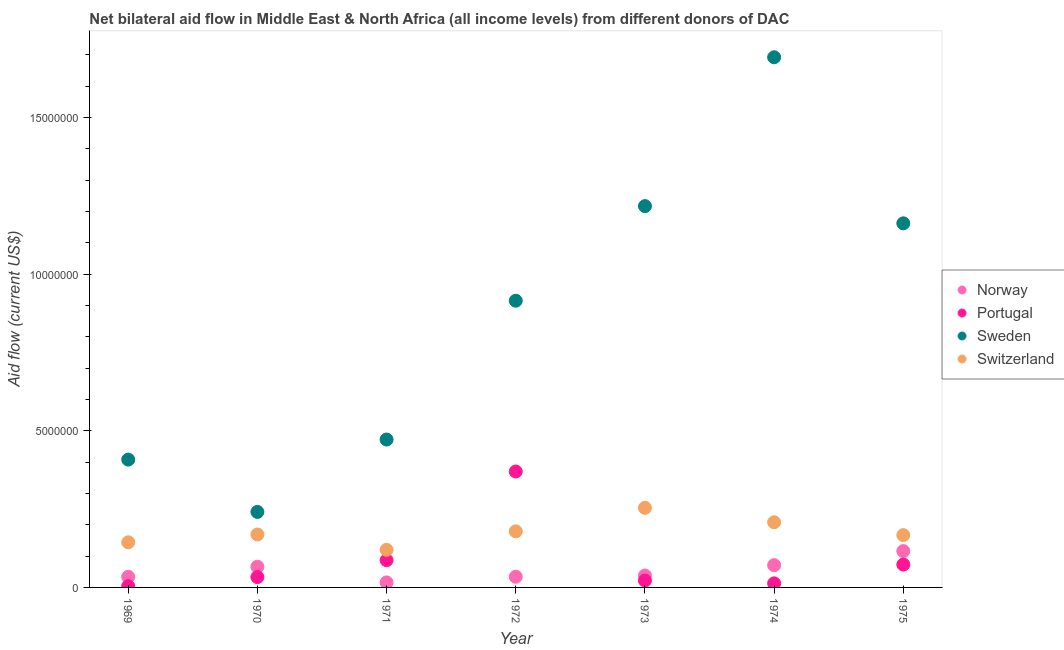How many different coloured dotlines are there?
Offer a terse response. 4. Is the number of dotlines equal to the number of legend labels?
Provide a succinct answer. Yes. What is the amount of aid given by norway in 1973?
Provide a short and direct response. 3.80e+05. Across all years, what is the maximum amount of aid given by norway?
Keep it short and to the point. 1.16e+06. Across all years, what is the minimum amount of aid given by norway?
Provide a succinct answer. 1.60e+05. In which year was the amount of aid given by portugal minimum?
Make the answer very short. 1969. What is the total amount of aid given by sweden in the graph?
Keep it short and to the point. 6.11e+07. What is the difference between the amount of aid given by switzerland in 1969 and that in 1972?
Offer a very short reply. -3.50e+05. What is the difference between the amount of aid given by switzerland in 1969 and the amount of aid given by portugal in 1970?
Ensure brevity in your answer.  1.11e+06. What is the average amount of aid given by portugal per year?
Your response must be concise. 8.60e+05. In the year 1975, what is the difference between the amount of aid given by portugal and amount of aid given by norway?
Offer a very short reply. -4.30e+05. What is the ratio of the amount of aid given by norway in 1974 to that in 1975?
Provide a succinct answer. 0.61. What is the difference between the highest and the lowest amount of aid given by switzerland?
Give a very brief answer. 1.34e+06. In how many years, is the amount of aid given by portugal greater than the average amount of aid given by portugal taken over all years?
Provide a short and direct response. 2. Is the sum of the amount of aid given by sweden in 1973 and 1975 greater than the maximum amount of aid given by norway across all years?
Your answer should be compact. Yes. Is the amount of aid given by switzerland strictly greater than the amount of aid given by sweden over the years?
Give a very brief answer. No. Does the graph contain grids?
Give a very brief answer. No. How many legend labels are there?
Make the answer very short. 4. How are the legend labels stacked?
Keep it short and to the point. Vertical. What is the title of the graph?
Give a very brief answer. Net bilateral aid flow in Middle East & North Africa (all income levels) from different donors of DAC. What is the label or title of the Y-axis?
Keep it short and to the point. Aid flow (current US$). What is the Aid flow (current US$) of Sweden in 1969?
Provide a succinct answer. 4.08e+06. What is the Aid flow (current US$) in Switzerland in 1969?
Offer a very short reply. 1.44e+06. What is the Aid flow (current US$) of Sweden in 1970?
Keep it short and to the point. 2.41e+06. What is the Aid flow (current US$) of Switzerland in 1970?
Keep it short and to the point. 1.69e+06. What is the Aid flow (current US$) of Norway in 1971?
Your response must be concise. 1.60e+05. What is the Aid flow (current US$) of Portugal in 1971?
Offer a terse response. 8.70e+05. What is the Aid flow (current US$) of Sweden in 1971?
Make the answer very short. 4.72e+06. What is the Aid flow (current US$) of Switzerland in 1971?
Your response must be concise. 1.20e+06. What is the Aid flow (current US$) of Norway in 1972?
Your response must be concise. 3.40e+05. What is the Aid flow (current US$) in Portugal in 1972?
Make the answer very short. 3.70e+06. What is the Aid flow (current US$) of Sweden in 1972?
Offer a terse response. 9.15e+06. What is the Aid flow (current US$) in Switzerland in 1972?
Offer a very short reply. 1.79e+06. What is the Aid flow (current US$) in Sweden in 1973?
Offer a terse response. 1.22e+07. What is the Aid flow (current US$) in Switzerland in 1973?
Provide a succinct answer. 2.54e+06. What is the Aid flow (current US$) in Norway in 1974?
Provide a succinct answer. 7.10e+05. What is the Aid flow (current US$) in Portugal in 1974?
Provide a succinct answer. 1.30e+05. What is the Aid flow (current US$) in Sweden in 1974?
Give a very brief answer. 1.69e+07. What is the Aid flow (current US$) in Switzerland in 1974?
Your response must be concise. 2.08e+06. What is the Aid flow (current US$) of Norway in 1975?
Offer a very short reply. 1.16e+06. What is the Aid flow (current US$) in Portugal in 1975?
Offer a very short reply. 7.30e+05. What is the Aid flow (current US$) of Sweden in 1975?
Provide a short and direct response. 1.16e+07. What is the Aid flow (current US$) in Switzerland in 1975?
Offer a very short reply. 1.67e+06. Across all years, what is the maximum Aid flow (current US$) in Norway?
Offer a terse response. 1.16e+06. Across all years, what is the maximum Aid flow (current US$) of Portugal?
Make the answer very short. 3.70e+06. Across all years, what is the maximum Aid flow (current US$) of Sweden?
Your response must be concise. 1.69e+07. Across all years, what is the maximum Aid flow (current US$) in Switzerland?
Provide a succinct answer. 2.54e+06. Across all years, what is the minimum Aid flow (current US$) of Norway?
Provide a succinct answer. 1.60e+05. Across all years, what is the minimum Aid flow (current US$) in Sweden?
Provide a succinct answer. 2.41e+06. Across all years, what is the minimum Aid flow (current US$) in Switzerland?
Your response must be concise. 1.20e+06. What is the total Aid flow (current US$) of Norway in the graph?
Offer a very short reply. 3.75e+06. What is the total Aid flow (current US$) of Portugal in the graph?
Provide a succinct answer. 6.02e+06. What is the total Aid flow (current US$) of Sweden in the graph?
Make the answer very short. 6.11e+07. What is the total Aid flow (current US$) in Switzerland in the graph?
Keep it short and to the point. 1.24e+07. What is the difference between the Aid flow (current US$) of Norway in 1969 and that in 1970?
Provide a succinct answer. -3.20e+05. What is the difference between the Aid flow (current US$) in Portugal in 1969 and that in 1970?
Give a very brief answer. -2.90e+05. What is the difference between the Aid flow (current US$) in Sweden in 1969 and that in 1970?
Ensure brevity in your answer.  1.67e+06. What is the difference between the Aid flow (current US$) in Switzerland in 1969 and that in 1970?
Keep it short and to the point. -2.50e+05. What is the difference between the Aid flow (current US$) in Portugal in 1969 and that in 1971?
Offer a very short reply. -8.30e+05. What is the difference between the Aid flow (current US$) of Sweden in 1969 and that in 1971?
Offer a very short reply. -6.40e+05. What is the difference between the Aid flow (current US$) in Switzerland in 1969 and that in 1971?
Your response must be concise. 2.40e+05. What is the difference between the Aid flow (current US$) of Portugal in 1969 and that in 1972?
Keep it short and to the point. -3.66e+06. What is the difference between the Aid flow (current US$) of Sweden in 1969 and that in 1972?
Provide a succinct answer. -5.07e+06. What is the difference between the Aid flow (current US$) of Switzerland in 1969 and that in 1972?
Keep it short and to the point. -3.50e+05. What is the difference between the Aid flow (current US$) of Sweden in 1969 and that in 1973?
Offer a very short reply. -8.09e+06. What is the difference between the Aid flow (current US$) of Switzerland in 1969 and that in 1973?
Provide a succinct answer. -1.10e+06. What is the difference between the Aid flow (current US$) of Norway in 1969 and that in 1974?
Give a very brief answer. -3.70e+05. What is the difference between the Aid flow (current US$) of Portugal in 1969 and that in 1974?
Offer a terse response. -9.00e+04. What is the difference between the Aid flow (current US$) in Sweden in 1969 and that in 1974?
Provide a succinct answer. -1.28e+07. What is the difference between the Aid flow (current US$) in Switzerland in 1969 and that in 1974?
Provide a short and direct response. -6.40e+05. What is the difference between the Aid flow (current US$) in Norway in 1969 and that in 1975?
Provide a short and direct response. -8.20e+05. What is the difference between the Aid flow (current US$) of Portugal in 1969 and that in 1975?
Ensure brevity in your answer.  -6.90e+05. What is the difference between the Aid flow (current US$) in Sweden in 1969 and that in 1975?
Give a very brief answer. -7.54e+06. What is the difference between the Aid flow (current US$) in Norway in 1970 and that in 1971?
Ensure brevity in your answer.  5.00e+05. What is the difference between the Aid flow (current US$) in Portugal in 1970 and that in 1971?
Give a very brief answer. -5.40e+05. What is the difference between the Aid flow (current US$) of Sweden in 1970 and that in 1971?
Keep it short and to the point. -2.31e+06. What is the difference between the Aid flow (current US$) of Portugal in 1970 and that in 1972?
Keep it short and to the point. -3.37e+06. What is the difference between the Aid flow (current US$) in Sweden in 1970 and that in 1972?
Make the answer very short. -6.74e+06. What is the difference between the Aid flow (current US$) of Portugal in 1970 and that in 1973?
Your answer should be compact. 1.10e+05. What is the difference between the Aid flow (current US$) of Sweden in 1970 and that in 1973?
Offer a very short reply. -9.76e+06. What is the difference between the Aid flow (current US$) in Switzerland in 1970 and that in 1973?
Your answer should be very brief. -8.50e+05. What is the difference between the Aid flow (current US$) of Portugal in 1970 and that in 1974?
Provide a succinct answer. 2.00e+05. What is the difference between the Aid flow (current US$) in Sweden in 1970 and that in 1974?
Keep it short and to the point. -1.45e+07. What is the difference between the Aid flow (current US$) in Switzerland in 1970 and that in 1974?
Make the answer very short. -3.90e+05. What is the difference between the Aid flow (current US$) of Norway in 1970 and that in 1975?
Your answer should be very brief. -5.00e+05. What is the difference between the Aid flow (current US$) of Portugal in 1970 and that in 1975?
Your answer should be very brief. -4.00e+05. What is the difference between the Aid flow (current US$) in Sweden in 1970 and that in 1975?
Ensure brevity in your answer.  -9.21e+06. What is the difference between the Aid flow (current US$) of Switzerland in 1970 and that in 1975?
Provide a short and direct response. 2.00e+04. What is the difference between the Aid flow (current US$) of Portugal in 1971 and that in 1972?
Keep it short and to the point. -2.83e+06. What is the difference between the Aid flow (current US$) in Sweden in 1971 and that in 1972?
Your answer should be very brief. -4.43e+06. What is the difference between the Aid flow (current US$) in Switzerland in 1971 and that in 1972?
Give a very brief answer. -5.90e+05. What is the difference between the Aid flow (current US$) of Norway in 1971 and that in 1973?
Offer a terse response. -2.20e+05. What is the difference between the Aid flow (current US$) of Portugal in 1971 and that in 1973?
Your response must be concise. 6.50e+05. What is the difference between the Aid flow (current US$) in Sweden in 1971 and that in 1973?
Your answer should be very brief. -7.45e+06. What is the difference between the Aid flow (current US$) of Switzerland in 1971 and that in 1973?
Keep it short and to the point. -1.34e+06. What is the difference between the Aid flow (current US$) of Norway in 1971 and that in 1974?
Your answer should be compact. -5.50e+05. What is the difference between the Aid flow (current US$) of Portugal in 1971 and that in 1974?
Give a very brief answer. 7.40e+05. What is the difference between the Aid flow (current US$) in Sweden in 1971 and that in 1974?
Your response must be concise. -1.22e+07. What is the difference between the Aid flow (current US$) in Switzerland in 1971 and that in 1974?
Offer a terse response. -8.80e+05. What is the difference between the Aid flow (current US$) in Norway in 1971 and that in 1975?
Provide a succinct answer. -1.00e+06. What is the difference between the Aid flow (current US$) of Sweden in 1971 and that in 1975?
Ensure brevity in your answer.  -6.90e+06. What is the difference between the Aid flow (current US$) of Switzerland in 1971 and that in 1975?
Offer a terse response. -4.70e+05. What is the difference between the Aid flow (current US$) of Portugal in 1972 and that in 1973?
Your answer should be compact. 3.48e+06. What is the difference between the Aid flow (current US$) of Sweden in 1972 and that in 1973?
Provide a succinct answer. -3.02e+06. What is the difference between the Aid flow (current US$) of Switzerland in 1972 and that in 1973?
Provide a short and direct response. -7.50e+05. What is the difference between the Aid flow (current US$) in Norway in 1972 and that in 1974?
Give a very brief answer. -3.70e+05. What is the difference between the Aid flow (current US$) in Portugal in 1972 and that in 1974?
Offer a very short reply. 3.57e+06. What is the difference between the Aid flow (current US$) in Sweden in 1972 and that in 1974?
Offer a very short reply. -7.77e+06. What is the difference between the Aid flow (current US$) in Norway in 1972 and that in 1975?
Ensure brevity in your answer.  -8.20e+05. What is the difference between the Aid flow (current US$) of Portugal in 1972 and that in 1975?
Make the answer very short. 2.97e+06. What is the difference between the Aid flow (current US$) in Sweden in 1972 and that in 1975?
Make the answer very short. -2.47e+06. What is the difference between the Aid flow (current US$) in Norway in 1973 and that in 1974?
Provide a short and direct response. -3.30e+05. What is the difference between the Aid flow (current US$) of Sweden in 1973 and that in 1974?
Provide a succinct answer. -4.75e+06. What is the difference between the Aid flow (current US$) in Norway in 1973 and that in 1975?
Your answer should be compact. -7.80e+05. What is the difference between the Aid flow (current US$) of Portugal in 1973 and that in 1975?
Ensure brevity in your answer.  -5.10e+05. What is the difference between the Aid flow (current US$) in Sweden in 1973 and that in 1975?
Make the answer very short. 5.50e+05. What is the difference between the Aid flow (current US$) in Switzerland in 1973 and that in 1975?
Your answer should be very brief. 8.70e+05. What is the difference between the Aid flow (current US$) of Norway in 1974 and that in 1975?
Provide a succinct answer. -4.50e+05. What is the difference between the Aid flow (current US$) of Portugal in 1974 and that in 1975?
Your answer should be very brief. -6.00e+05. What is the difference between the Aid flow (current US$) in Sweden in 1974 and that in 1975?
Your answer should be compact. 5.30e+06. What is the difference between the Aid flow (current US$) of Norway in 1969 and the Aid flow (current US$) of Portugal in 1970?
Offer a terse response. 10000. What is the difference between the Aid flow (current US$) in Norway in 1969 and the Aid flow (current US$) in Sweden in 1970?
Provide a short and direct response. -2.07e+06. What is the difference between the Aid flow (current US$) in Norway in 1969 and the Aid flow (current US$) in Switzerland in 1970?
Your response must be concise. -1.35e+06. What is the difference between the Aid flow (current US$) of Portugal in 1969 and the Aid flow (current US$) of Sweden in 1970?
Your response must be concise. -2.37e+06. What is the difference between the Aid flow (current US$) of Portugal in 1969 and the Aid flow (current US$) of Switzerland in 1970?
Provide a succinct answer. -1.65e+06. What is the difference between the Aid flow (current US$) in Sweden in 1969 and the Aid flow (current US$) in Switzerland in 1970?
Your response must be concise. 2.39e+06. What is the difference between the Aid flow (current US$) in Norway in 1969 and the Aid flow (current US$) in Portugal in 1971?
Make the answer very short. -5.30e+05. What is the difference between the Aid flow (current US$) of Norway in 1969 and the Aid flow (current US$) of Sweden in 1971?
Your answer should be very brief. -4.38e+06. What is the difference between the Aid flow (current US$) in Norway in 1969 and the Aid flow (current US$) in Switzerland in 1971?
Provide a short and direct response. -8.60e+05. What is the difference between the Aid flow (current US$) in Portugal in 1969 and the Aid flow (current US$) in Sweden in 1971?
Your answer should be very brief. -4.68e+06. What is the difference between the Aid flow (current US$) in Portugal in 1969 and the Aid flow (current US$) in Switzerland in 1971?
Your answer should be very brief. -1.16e+06. What is the difference between the Aid flow (current US$) in Sweden in 1969 and the Aid flow (current US$) in Switzerland in 1971?
Offer a terse response. 2.88e+06. What is the difference between the Aid flow (current US$) in Norway in 1969 and the Aid flow (current US$) in Portugal in 1972?
Provide a short and direct response. -3.36e+06. What is the difference between the Aid flow (current US$) of Norway in 1969 and the Aid flow (current US$) of Sweden in 1972?
Give a very brief answer. -8.81e+06. What is the difference between the Aid flow (current US$) in Norway in 1969 and the Aid flow (current US$) in Switzerland in 1972?
Keep it short and to the point. -1.45e+06. What is the difference between the Aid flow (current US$) of Portugal in 1969 and the Aid flow (current US$) of Sweden in 1972?
Give a very brief answer. -9.11e+06. What is the difference between the Aid flow (current US$) in Portugal in 1969 and the Aid flow (current US$) in Switzerland in 1972?
Provide a succinct answer. -1.75e+06. What is the difference between the Aid flow (current US$) in Sweden in 1969 and the Aid flow (current US$) in Switzerland in 1972?
Give a very brief answer. 2.29e+06. What is the difference between the Aid flow (current US$) in Norway in 1969 and the Aid flow (current US$) in Sweden in 1973?
Give a very brief answer. -1.18e+07. What is the difference between the Aid flow (current US$) of Norway in 1969 and the Aid flow (current US$) of Switzerland in 1973?
Provide a short and direct response. -2.20e+06. What is the difference between the Aid flow (current US$) of Portugal in 1969 and the Aid flow (current US$) of Sweden in 1973?
Provide a short and direct response. -1.21e+07. What is the difference between the Aid flow (current US$) in Portugal in 1969 and the Aid flow (current US$) in Switzerland in 1973?
Make the answer very short. -2.50e+06. What is the difference between the Aid flow (current US$) of Sweden in 1969 and the Aid flow (current US$) of Switzerland in 1973?
Provide a short and direct response. 1.54e+06. What is the difference between the Aid flow (current US$) of Norway in 1969 and the Aid flow (current US$) of Sweden in 1974?
Give a very brief answer. -1.66e+07. What is the difference between the Aid flow (current US$) of Norway in 1969 and the Aid flow (current US$) of Switzerland in 1974?
Your response must be concise. -1.74e+06. What is the difference between the Aid flow (current US$) in Portugal in 1969 and the Aid flow (current US$) in Sweden in 1974?
Provide a short and direct response. -1.69e+07. What is the difference between the Aid flow (current US$) in Portugal in 1969 and the Aid flow (current US$) in Switzerland in 1974?
Ensure brevity in your answer.  -2.04e+06. What is the difference between the Aid flow (current US$) in Norway in 1969 and the Aid flow (current US$) in Portugal in 1975?
Give a very brief answer. -3.90e+05. What is the difference between the Aid flow (current US$) of Norway in 1969 and the Aid flow (current US$) of Sweden in 1975?
Ensure brevity in your answer.  -1.13e+07. What is the difference between the Aid flow (current US$) in Norway in 1969 and the Aid flow (current US$) in Switzerland in 1975?
Offer a terse response. -1.33e+06. What is the difference between the Aid flow (current US$) of Portugal in 1969 and the Aid flow (current US$) of Sweden in 1975?
Make the answer very short. -1.16e+07. What is the difference between the Aid flow (current US$) of Portugal in 1969 and the Aid flow (current US$) of Switzerland in 1975?
Your answer should be very brief. -1.63e+06. What is the difference between the Aid flow (current US$) in Sweden in 1969 and the Aid flow (current US$) in Switzerland in 1975?
Ensure brevity in your answer.  2.41e+06. What is the difference between the Aid flow (current US$) in Norway in 1970 and the Aid flow (current US$) in Sweden in 1971?
Your answer should be compact. -4.06e+06. What is the difference between the Aid flow (current US$) in Norway in 1970 and the Aid flow (current US$) in Switzerland in 1971?
Ensure brevity in your answer.  -5.40e+05. What is the difference between the Aid flow (current US$) in Portugal in 1970 and the Aid flow (current US$) in Sweden in 1971?
Offer a very short reply. -4.39e+06. What is the difference between the Aid flow (current US$) of Portugal in 1970 and the Aid flow (current US$) of Switzerland in 1971?
Make the answer very short. -8.70e+05. What is the difference between the Aid flow (current US$) of Sweden in 1970 and the Aid flow (current US$) of Switzerland in 1971?
Your answer should be very brief. 1.21e+06. What is the difference between the Aid flow (current US$) in Norway in 1970 and the Aid flow (current US$) in Portugal in 1972?
Provide a short and direct response. -3.04e+06. What is the difference between the Aid flow (current US$) of Norway in 1970 and the Aid flow (current US$) of Sweden in 1972?
Give a very brief answer. -8.49e+06. What is the difference between the Aid flow (current US$) in Norway in 1970 and the Aid flow (current US$) in Switzerland in 1972?
Your answer should be compact. -1.13e+06. What is the difference between the Aid flow (current US$) in Portugal in 1970 and the Aid flow (current US$) in Sweden in 1972?
Your answer should be very brief. -8.82e+06. What is the difference between the Aid flow (current US$) of Portugal in 1970 and the Aid flow (current US$) of Switzerland in 1972?
Your answer should be compact. -1.46e+06. What is the difference between the Aid flow (current US$) of Sweden in 1970 and the Aid flow (current US$) of Switzerland in 1972?
Keep it short and to the point. 6.20e+05. What is the difference between the Aid flow (current US$) of Norway in 1970 and the Aid flow (current US$) of Portugal in 1973?
Provide a short and direct response. 4.40e+05. What is the difference between the Aid flow (current US$) in Norway in 1970 and the Aid flow (current US$) in Sweden in 1973?
Give a very brief answer. -1.15e+07. What is the difference between the Aid flow (current US$) in Norway in 1970 and the Aid flow (current US$) in Switzerland in 1973?
Your answer should be compact. -1.88e+06. What is the difference between the Aid flow (current US$) of Portugal in 1970 and the Aid flow (current US$) of Sweden in 1973?
Give a very brief answer. -1.18e+07. What is the difference between the Aid flow (current US$) of Portugal in 1970 and the Aid flow (current US$) of Switzerland in 1973?
Your answer should be compact. -2.21e+06. What is the difference between the Aid flow (current US$) of Norway in 1970 and the Aid flow (current US$) of Portugal in 1974?
Offer a terse response. 5.30e+05. What is the difference between the Aid flow (current US$) in Norway in 1970 and the Aid flow (current US$) in Sweden in 1974?
Give a very brief answer. -1.63e+07. What is the difference between the Aid flow (current US$) of Norway in 1970 and the Aid flow (current US$) of Switzerland in 1974?
Ensure brevity in your answer.  -1.42e+06. What is the difference between the Aid flow (current US$) in Portugal in 1970 and the Aid flow (current US$) in Sweden in 1974?
Provide a short and direct response. -1.66e+07. What is the difference between the Aid flow (current US$) in Portugal in 1970 and the Aid flow (current US$) in Switzerland in 1974?
Your answer should be compact. -1.75e+06. What is the difference between the Aid flow (current US$) of Sweden in 1970 and the Aid flow (current US$) of Switzerland in 1974?
Ensure brevity in your answer.  3.30e+05. What is the difference between the Aid flow (current US$) in Norway in 1970 and the Aid flow (current US$) in Sweden in 1975?
Provide a short and direct response. -1.10e+07. What is the difference between the Aid flow (current US$) of Norway in 1970 and the Aid flow (current US$) of Switzerland in 1975?
Your answer should be very brief. -1.01e+06. What is the difference between the Aid flow (current US$) in Portugal in 1970 and the Aid flow (current US$) in Sweden in 1975?
Make the answer very short. -1.13e+07. What is the difference between the Aid flow (current US$) of Portugal in 1970 and the Aid flow (current US$) of Switzerland in 1975?
Keep it short and to the point. -1.34e+06. What is the difference between the Aid flow (current US$) in Sweden in 1970 and the Aid flow (current US$) in Switzerland in 1975?
Ensure brevity in your answer.  7.40e+05. What is the difference between the Aid flow (current US$) of Norway in 1971 and the Aid flow (current US$) of Portugal in 1972?
Your answer should be compact. -3.54e+06. What is the difference between the Aid flow (current US$) in Norway in 1971 and the Aid flow (current US$) in Sweden in 1972?
Offer a very short reply. -8.99e+06. What is the difference between the Aid flow (current US$) of Norway in 1971 and the Aid flow (current US$) of Switzerland in 1972?
Your response must be concise. -1.63e+06. What is the difference between the Aid flow (current US$) of Portugal in 1971 and the Aid flow (current US$) of Sweden in 1972?
Provide a succinct answer. -8.28e+06. What is the difference between the Aid flow (current US$) in Portugal in 1971 and the Aid flow (current US$) in Switzerland in 1972?
Provide a succinct answer. -9.20e+05. What is the difference between the Aid flow (current US$) in Sweden in 1971 and the Aid flow (current US$) in Switzerland in 1972?
Your response must be concise. 2.93e+06. What is the difference between the Aid flow (current US$) of Norway in 1971 and the Aid flow (current US$) of Portugal in 1973?
Give a very brief answer. -6.00e+04. What is the difference between the Aid flow (current US$) of Norway in 1971 and the Aid flow (current US$) of Sweden in 1973?
Offer a terse response. -1.20e+07. What is the difference between the Aid flow (current US$) of Norway in 1971 and the Aid flow (current US$) of Switzerland in 1973?
Keep it short and to the point. -2.38e+06. What is the difference between the Aid flow (current US$) of Portugal in 1971 and the Aid flow (current US$) of Sweden in 1973?
Offer a terse response. -1.13e+07. What is the difference between the Aid flow (current US$) of Portugal in 1971 and the Aid flow (current US$) of Switzerland in 1973?
Provide a succinct answer. -1.67e+06. What is the difference between the Aid flow (current US$) in Sweden in 1971 and the Aid flow (current US$) in Switzerland in 1973?
Provide a succinct answer. 2.18e+06. What is the difference between the Aid flow (current US$) of Norway in 1971 and the Aid flow (current US$) of Portugal in 1974?
Make the answer very short. 3.00e+04. What is the difference between the Aid flow (current US$) of Norway in 1971 and the Aid flow (current US$) of Sweden in 1974?
Give a very brief answer. -1.68e+07. What is the difference between the Aid flow (current US$) of Norway in 1971 and the Aid flow (current US$) of Switzerland in 1974?
Offer a terse response. -1.92e+06. What is the difference between the Aid flow (current US$) of Portugal in 1971 and the Aid flow (current US$) of Sweden in 1974?
Your answer should be compact. -1.60e+07. What is the difference between the Aid flow (current US$) of Portugal in 1971 and the Aid flow (current US$) of Switzerland in 1974?
Provide a short and direct response. -1.21e+06. What is the difference between the Aid flow (current US$) in Sweden in 1971 and the Aid flow (current US$) in Switzerland in 1974?
Offer a terse response. 2.64e+06. What is the difference between the Aid flow (current US$) in Norway in 1971 and the Aid flow (current US$) in Portugal in 1975?
Make the answer very short. -5.70e+05. What is the difference between the Aid flow (current US$) in Norway in 1971 and the Aid flow (current US$) in Sweden in 1975?
Your answer should be compact. -1.15e+07. What is the difference between the Aid flow (current US$) of Norway in 1971 and the Aid flow (current US$) of Switzerland in 1975?
Ensure brevity in your answer.  -1.51e+06. What is the difference between the Aid flow (current US$) of Portugal in 1971 and the Aid flow (current US$) of Sweden in 1975?
Your response must be concise. -1.08e+07. What is the difference between the Aid flow (current US$) of Portugal in 1971 and the Aid flow (current US$) of Switzerland in 1975?
Offer a very short reply. -8.00e+05. What is the difference between the Aid flow (current US$) of Sweden in 1971 and the Aid flow (current US$) of Switzerland in 1975?
Your answer should be very brief. 3.05e+06. What is the difference between the Aid flow (current US$) in Norway in 1972 and the Aid flow (current US$) in Portugal in 1973?
Provide a succinct answer. 1.20e+05. What is the difference between the Aid flow (current US$) in Norway in 1972 and the Aid flow (current US$) in Sweden in 1973?
Provide a succinct answer. -1.18e+07. What is the difference between the Aid flow (current US$) in Norway in 1972 and the Aid flow (current US$) in Switzerland in 1973?
Offer a very short reply. -2.20e+06. What is the difference between the Aid flow (current US$) in Portugal in 1972 and the Aid flow (current US$) in Sweden in 1973?
Give a very brief answer. -8.47e+06. What is the difference between the Aid flow (current US$) in Portugal in 1972 and the Aid flow (current US$) in Switzerland in 1973?
Offer a terse response. 1.16e+06. What is the difference between the Aid flow (current US$) in Sweden in 1972 and the Aid flow (current US$) in Switzerland in 1973?
Make the answer very short. 6.61e+06. What is the difference between the Aid flow (current US$) of Norway in 1972 and the Aid flow (current US$) of Sweden in 1974?
Your answer should be compact. -1.66e+07. What is the difference between the Aid flow (current US$) of Norway in 1972 and the Aid flow (current US$) of Switzerland in 1974?
Ensure brevity in your answer.  -1.74e+06. What is the difference between the Aid flow (current US$) of Portugal in 1972 and the Aid flow (current US$) of Sweden in 1974?
Offer a very short reply. -1.32e+07. What is the difference between the Aid flow (current US$) of Portugal in 1972 and the Aid flow (current US$) of Switzerland in 1974?
Your answer should be compact. 1.62e+06. What is the difference between the Aid flow (current US$) in Sweden in 1972 and the Aid flow (current US$) in Switzerland in 1974?
Offer a very short reply. 7.07e+06. What is the difference between the Aid flow (current US$) in Norway in 1972 and the Aid flow (current US$) in Portugal in 1975?
Your answer should be very brief. -3.90e+05. What is the difference between the Aid flow (current US$) in Norway in 1972 and the Aid flow (current US$) in Sweden in 1975?
Your answer should be compact. -1.13e+07. What is the difference between the Aid flow (current US$) of Norway in 1972 and the Aid flow (current US$) of Switzerland in 1975?
Your answer should be very brief. -1.33e+06. What is the difference between the Aid flow (current US$) of Portugal in 1972 and the Aid flow (current US$) of Sweden in 1975?
Offer a terse response. -7.92e+06. What is the difference between the Aid flow (current US$) of Portugal in 1972 and the Aid flow (current US$) of Switzerland in 1975?
Keep it short and to the point. 2.03e+06. What is the difference between the Aid flow (current US$) of Sweden in 1972 and the Aid flow (current US$) of Switzerland in 1975?
Give a very brief answer. 7.48e+06. What is the difference between the Aid flow (current US$) of Norway in 1973 and the Aid flow (current US$) of Sweden in 1974?
Provide a short and direct response. -1.65e+07. What is the difference between the Aid flow (current US$) of Norway in 1973 and the Aid flow (current US$) of Switzerland in 1974?
Keep it short and to the point. -1.70e+06. What is the difference between the Aid flow (current US$) of Portugal in 1973 and the Aid flow (current US$) of Sweden in 1974?
Provide a succinct answer. -1.67e+07. What is the difference between the Aid flow (current US$) of Portugal in 1973 and the Aid flow (current US$) of Switzerland in 1974?
Offer a terse response. -1.86e+06. What is the difference between the Aid flow (current US$) of Sweden in 1973 and the Aid flow (current US$) of Switzerland in 1974?
Your answer should be compact. 1.01e+07. What is the difference between the Aid flow (current US$) of Norway in 1973 and the Aid flow (current US$) of Portugal in 1975?
Your answer should be very brief. -3.50e+05. What is the difference between the Aid flow (current US$) of Norway in 1973 and the Aid flow (current US$) of Sweden in 1975?
Offer a terse response. -1.12e+07. What is the difference between the Aid flow (current US$) in Norway in 1973 and the Aid flow (current US$) in Switzerland in 1975?
Make the answer very short. -1.29e+06. What is the difference between the Aid flow (current US$) of Portugal in 1973 and the Aid flow (current US$) of Sweden in 1975?
Keep it short and to the point. -1.14e+07. What is the difference between the Aid flow (current US$) of Portugal in 1973 and the Aid flow (current US$) of Switzerland in 1975?
Give a very brief answer. -1.45e+06. What is the difference between the Aid flow (current US$) in Sweden in 1973 and the Aid flow (current US$) in Switzerland in 1975?
Your answer should be compact. 1.05e+07. What is the difference between the Aid flow (current US$) in Norway in 1974 and the Aid flow (current US$) in Portugal in 1975?
Ensure brevity in your answer.  -2.00e+04. What is the difference between the Aid flow (current US$) of Norway in 1974 and the Aid flow (current US$) of Sweden in 1975?
Your answer should be very brief. -1.09e+07. What is the difference between the Aid flow (current US$) in Norway in 1974 and the Aid flow (current US$) in Switzerland in 1975?
Ensure brevity in your answer.  -9.60e+05. What is the difference between the Aid flow (current US$) in Portugal in 1974 and the Aid flow (current US$) in Sweden in 1975?
Offer a very short reply. -1.15e+07. What is the difference between the Aid flow (current US$) in Portugal in 1974 and the Aid flow (current US$) in Switzerland in 1975?
Offer a very short reply. -1.54e+06. What is the difference between the Aid flow (current US$) in Sweden in 1974 and the Aid flow (current US$) in Switzerland in 1975?
Your answer should be very brief. 1.52e+07. What is the average Aid flow (current US$) of Norway per year?
Offer a very short reply. 5.36e+05. What is the average Aid flow (current US$) of Portugal per year?
Your answer should be very brief. 8.60e+05. What is the average Aid flow (current US$) of Sweden per year?
Offer a very short reply. 8.72e+06. What is the average Aid flow (current US$) of Switzerland per year?
Keep it short and to the point. 1.77e+06. In the year 1969, what is the difference between the Aid flow (current US$) of Norway and Aid flow (current US$) of Portugal?
Offer a terse response. 3.00e+05. In the year 1969, what is the difference between the Aid flow (current US$) in Norway and Aid flow (current US$) in Sweden?
Offer a very short reply. -3.74e+06. In the year 1969, what is the difference between the Aid flow (current US$) of Norway and Aid flow (current US$) of Switzerland?
Offer a terse response. -1.10e+06. In the year 1969, what is the difference between the Aid flow (current US$) of Portugal and Aid flow (current US$) of Sweden?
Ensure brevity in your answer.  -4.04e+06. In the year 1969, what is the difference between the Aid flow (current US$) in Portugal and Aid flow (current US$) in Switzerland?
Ensure brevity in your answer.  -1.40e+06. In the year 1969, what is the difference between the Aid flow (current US$) of Sweden and Aid flow (current US$) of Switzerland?
Provide a short and direct response. 2.64e+06. In the year 1970, what is the difference between the Aid flow (current US$) in Norway and Aid flow (current US$) in Portugal?
Your answer should be compact. 3.30e+05. In the year 1970, what is the difference between the Aid flow (current US$) of Norway and Aid flow (current US$) of Sweden?
Your response must be concise. -1.75e+06. In the year 1970, what is the difference between the Aid flow (current US$) in Norway and Aid flow (current US$) in Switzerland?
Offer a very short reply. -1.03e+06. In the year 1970, what is the difference between the Aid flow (current US$) in Portugal and Aid flow (current US$) in Sweden?
Your answer should be compact. -2.08e+06. In the year 1970, what is the difference between the Aid flow (current US$) in Portugal and Aid flow (current US$) in Switzerland?
Provide a short and direct response. -1.36e+06. In the year 1970, what is the difference between the Aid flow (current US$) in Sweden and Aid flow (current US$) in Switzerland?
Offer a terse response. 7.20e+05. In the year 1971, what is the difference between the Aid flow (current US$) of Norway and Aid flow (current US$) of Portugal?
Give a very brief answer. -7.10e+05. In the year 1971, what is the difference between the Aid flow (current US$) in Norway and Aid flow (current US$) in Sweden?
Provide a succinct answer. -4.56e+06. In the year 1971, what is the difference between the Aid flow (current US$) in Norway and Aid flow (current US$) in Switzerland?
Offer a very short reply. -1.04e+06. In the year 1971, what is the difference between the Aid flow (current US$) in Portugal and Aid flow (current US$) in Sweden?
Make the answer very short. -3.85e+06. In the year 1971, what is the difference between the Aid flow (current US$) of Portugal and Aid flow (current US$) of Switzerland?
Provide a succinct answer. -3.30e+05. In the year 1971, what is the difference between the Aid flow (current US$) in Sweden and Aid flow (current US$) in Switzerland?
Your answer should be compact. 3.52e+06. In the year 1972, what is the difference between the Aid flow (current US$) in Norway and Aid flow (current US$) in Portugal?
Your answer should be very brief. -3.36e+06. In the year 1972, what is the difference between the Aid flow (current US$) of Norway and Aid flow (current US$) of Sweden?
Provide a succinct answer. -8.81e+06. In the year 1972, what is the difference between the Aid flow (current US$) in Norway and Aid flow (current US$) in Switzerland?
Make the answer very short. -1.45e+06. In the year 1972, what is the difference between the Aid flow (current US$) of Portugal and Aid flow (current US$) of Sweden?
Your answer should be very brief. -5.45e+06. In the year 1972, what is the difference between the Aid flow (current US$) of Portugal and Aid flow (current US$) of Switzerland?
Give a very brief answer. 1.91e+06. In the year 1972, what is the difference between the Aid flow (current US$) of Sweden and Aid flow (current US$) of Switzerland?
Provide a short and direct response. 7.36e+06. In the year 1973, what is the difference between the Aid flow (current US$) of Norway and Aid flow (current US$) of Portugal?
Make the answer very short. 1.60e+05. In the year 1973, what is the difference between the Aid flow (current US$) of Norway and Aid flow (current US$) of Sweden?
Offer a very short reply. -1.18e+07. In the year 1973, what is the difference between the Aid flow (current US$) in Norway and Aid flow (current US$) in Switzerland?
Your answer should be very brief. -2.16e+06. In the year 1973, what is the difference between the Aid flow (current US$) of Portugal and Aid flow (current US$) of Sweden?
Your answer should be very brief. -1.20e+07. In the year 1973, what is the difference between the Aid flow (current US$) of Portugal and Aid flow (current US$) of Switzerland?
Keep it short and to the point. -2.32e+06. In the year 1973, what is the difference between the Aid flow (current US$) of Sweden and Aid flow (current US$) of Switzerland?
Your answer should be compact. 9.63e+06. In the year 1974, what is the difference between the Aid flow (current US$) of Norway and Aid flow (current US$) of Portugal?
Make the answer very short. 5.80e+05. In the year 1974, what is the difference between the Aid flow (current US$) of Norway and Aid flow (current US$) of Sweden?
Keep it short and to the point. -1.62e+07. In the year 1974, what is the difference between the Aid flow (current US$) in Norway and Aid flow (current US$) in Switzerland?
Offer a very short reply. -1.37e+06. In the year 1974, what is the difference between the Aid flow (current US$) in Portugal and Aid flow (current US$) in Sweden?
Your answer should be very brief. -1.68e+07. In the year 1974, what is the difference between the Aid flow (current US$) of Portugal and Aid flow (current US$) of Switzerland?
Provide a succinct answer. -1.95e+06. In the year 1974, what is the difference between the Aid flow (current US$) in Sweden and Aid flow (current US$) in Switzerland?
Your answer should be compact. 1.48e+07. In the year 1975, what is the difference between the Aid flow (current US$) of Norway and Aid flow (current US$) of Portugal?
Offer a terse response. 4.30e+05. In the year 1975, what is the difference between the Aid flow (current US$) of Norway and Aid flow (current US$) of Sweden?
Offer a very short reply. -1.05e+07. In the year 1975, what is the difference between the Aid flow (current US$) of Norway and Aid flow (current US$) of Switzerland?
Provide a succinct answer. -5.10e+05. In the year 1975, what is the difference between the Aid flow (current US$) in Portugal and Aid flow (current US$) in Sweden?
Your response must be concise. -1.09e+07. In the year 1975, what is the difference between the Aid flow (current US$) in Portugal and Aid flow (current US$) in Switzerland?
Give a very brief answer. -9.40e+05. In the year 1975, what is the difference between the Aid flow (current US$) of Sweden and Aid flow (current US$) of Switzerland?
Provide a succinct answer. 9.95e+06. What is the ratio of the Aid flow (current US$) in Norway in 1969 to that in 1970?
Offer a very short reply. 0.52. What is the ratio of the Aid flow (current US$) of Portugal in 1969 to that in 1970?
Ensure brevity in your answer.  0.12. What is the ratio of the Aid flow (current US$) in Sweden in 1969 to that in 1970?
Make the answer very short. 1.69. What is the ratio of the Aid flow (current US$) of Switzerland in 1969 to that in 1970?
Ensure brevity in your answer.  0.85. What is the ratio of the Aid flow (current US$) of Norway in 1969 to that in 1971?
Your answer should be compact. 2.12. What is the ratio of the Aid flow (current US$) of Portugal in 1969 to that in 1971?
Offer a terse response. 0.05. What is the ratio of the Aid flow (current US$) in Sweden in 1969 to that in 1971?
Provide a succinct answer. 0.86. What is the ratio of the Aid flow (current US$) in Norway in 1969 to that in 1972?
Ensure brevity in your answer.  1. What is the ratio of the Aid flow (current US$) of Portugal in 1969 to that in 1972?
Offer a very short reply. 0.01. What is the ratio of the Aid flow (current US$) of Sweden in 1969 to that in 1972?
Your answer should be compact. 0.45. What is the ratio of the Aid flow (current US$) in Switzerland in 1969 to that in 1972?
Provide a succinct answer. 0.8. What is the ratio of the Aid flow (current US$) of Norway in 1969 to that in 1973?
Your response must be concise. 0.89. What is the ratio of the Aid flow (current US$) in Portugal in 1969 to that in 1973?
Offer a terse response. 0.18. What is the ratio of the Aid flow (current US$) of Sweden in 1969 to that in 1973?
Offer a terse response. 0.34. What is the ratio of the Aid flow (current US$) of Switzerland in 1969 to that in 1973?
Provide a short and direct response. 0.57. What is the ratio of the Aid flow (current US$) in Norway in 1969 to that in 1974?
Your answer should be very brief. 0.48. What is the ratio of the Aid flow (current US$) of Portugal in 1969 to that in 1974?
Provide a short and direct response. 0.31. What is the ratio of the Aid flow (current US$) of Sweden in 1969 to that in 1974?
Provide a succinct answer. 0.24. What is the ratio of the Aid flow (current US$) of Switzerland in 1969 to that in 1974?
Your answer should be compact. 0.69. What is the ratio of the Aid flow (current US$) in Norway in 1969 to that in 1975?
Provide a succinct answer. 0.29. What is the ratio of the Aid flow (current US$) of Portugal in 1969 to that in 1975?
Provide a succinct answer. 0.05. What is the ratio of the Aid flow (current US$) of Sweden in 1969 to that in 1975?
Provide a short and direct response. 0.35. What is the ratio of the Aid flow (current US$) of Switzerland in 1969 to that in 1975?
Provide a short and direct response. 0.86. What is the ratio of the Aid flow (current US$) in Norway in 1970 to that in 1971?
Ensure brevity in your answer.  4.12. What is the ratio of the Aid flow (current US$) of Portugal in 1970 to that in 1971?
Provide a succinct answer. 0.38. What is the ratio of the Aid flow (current US$) of Sweden in 1970 to that in 1971?
Offer a terse response. 0.51. What is the ratio of the Aid flow (current US$) in Switzerland in 1970 to that in 1971?
Your response must be concise. 1.41. What is the ratio of the Aid flow (current US$) of Norway in 1970 to that in 1972?
Offer a terse response. 1.94. What is the ratio of the Aid flow (current US$) in Portugal in 1970 to that in 1972?
Ensure brevity in your answer.  0.09. What is the ratio of the Aid flow (current US$) in Sweden in 1970 to that in 1972?
Keep it short and to the point. 0.26. What is the ratio of the Aid flow (current US$) of Switzerland in 1970 to that in 1972?
Give a very brief answer. 0.94. What is the ratio of the Aid flow (current US$) of Norway in 1970 to that in 1973?
Your response must be concise. 1.74. What is the ratio of the Aid flow (current US$) of Portugal in 1970 to that in 1973?
Your answer should be compact. 1.5. What is the ratio of the Aid flow (current US$) of Sweden in 1970 to that in 1973?
Offer a terse response. 0.2. What is the ratio of the Aid flow (current US$) in Switzerland in 1970 to that in 1973?
Your answer should be very brief. 0.67. What is the ratio of the Aid flow (current US$) of Norway in 1970 to that in 1974?
Provide a short and direct response. 0.93. What is the ratio of the Aid flow (current US$) in Portugal in 1970 to that in 1974?
Your response must be concise. 2.54. What is the ratio of the Aid flow (current US$) in Sweden in 1970 to that in 1974?
Your response must be concise. 0.14. What is the ratio of the Aid flow (current US$) in Switzerland in 1970 to that in 1974?
Offer a very short reply. 0.81. What is the ratio of the Aid flow (current US$) of Norway in 1970 to that in 1975?
Offer a very short reply. 0.57. What is the ratio of the Aid flow (current US$) of Portugal in 1970 to that in 1975?
Offer a terse response. 0.45. What is the ratio of the Aid flow (current US$) in Sweden in 1970 to that in 1975?
Offer a very short reply. 0.21. What is the ratio of the Aid flow (current US$) in Switzerland in 1970 to that in 1975?
Offer a terse response. 1.01. What is the ratio of the Aid flow (current US$) of Norway in 1971 to that in 1972?
Offer a terse response. 0.47. What is the ratio of the Aid flow (current US$) of Portugal in 1971 to that in 1972?
Your response must be concise. 0.24. What is the ratio of the Aid flow (current US$) of Sweden in 1971 to that in 1972?
Your answer should be very brief. 0.52. What is the ratio of the Aid flow (current US$) of Switzerland in 1971 to that in 1972?
Your response must be concise. 0.67. What is the ratio of the Aid flow (current US$) of Norway in 1971 to that in 1973?
Offer a very short reply. 0.42. What is the ratio of the Aid flow (current US$) in Portugal in 1971 to that in 1973?
Make the answer very short. 3.95. What is the ratio of the Aid flow (current US$) of Sweden in 1971 to that in 1973?
Provide a short and direct response. 0.39. What is the ratio of the Aid flow (current US$) of Switzerland in 1971 to that in 1973?
Provide a succinct answer. 0.47. What is the ratio of the Aid flow (current US$) in Norway in 1971 to that in 1974?
Provide a short and direct response. 0.23. What is the ratio of the Aid flow (current US$) of Portugal in 1971 to that in 1974?
Your response must be concise. 6.69. What is the ratio of the Aid flow (current US$) in Sweden in 1971 to that in 1974?
Provide a short and direct response. 0.28. What is the ratio of the Aid flow (current US$) of Switzerland in 1971 to that in 1974?
Your answer should be very brief. 0.58. What is the ratio of the Aid flow (current US$) of Norway in 1971 to that in 1975?
Provide a short and direct response. 0.14. What is the ratio of the Aid flow (current US$) in Portugal in 1971 to that in 1975?
Make the answer very short. 1.19. What is the ratio of the Aid flow (current US$) of Sweden in 1971 to that in 1975?
Ensure brevity in your answer.  0.41. What is the ratio of the Aid flow (current US$) in Switzerland in 1971 to that in 1975?
Offer a terse response. 0.72. What is the ratio of the Aid flow (current US$) of Norway in 1972 to that in 1973?
Your response must be concise. 0.89. What is the ratio of the Aid flow (current US$) in Portugal in 1972 to that in 1973?
Your response must be concise. 16.82. What is the ratio of the Aid flow (current US$) in Sweden in 1972 to that in 1973?
Offer a terse response. 0.75. What is the ratio of the Aid flow (current US$) of Switzerland in 1972 to that in 1973?
Make the answer very short. 0.7. What is the ratio of the Aid flow (current US$) in Norway in 1972 to that in 1974?
Your answer should be compact. 0.48. What is the ratio of the Aid flow (current US$) in Portugal in 1972 to that in 1974?
Your answer should be very brief. 28.46. What is the ratio of the Aid flow (current US$) in Sweden in 1972 to that in 1974?
Make the answer very short. 0.54. What is the ratio of the Aid flow (current US$) in Switzerland in 1972 to that in 1974?
Offer a terse response. 0.86. What is the ratio of the Aid flow (current US$) of Norway in 1972 to that in 1975?
Your answer should be compact. 0.29. What is the ratio of the Aid flow (current US$) of Portugal in 1972 to that in 1975?
Keep it short and to the point. 5.07. What is the ratio of the Aid flow (current US$) in Sweden in 1972 to that in 1975?
Provide a succinct answer. 0.79. What is the ratio of the Aid flow (current US$) of Switzerland in 1972 to that in 1975?
Offer a very short reply. 1.07. What is the ratio of the Aid flow (current US$) of Norway in 1973 to that in 1974?
Your response must be concise. 0.54. What is the ratio of the Aid flow (current US$) of Portugal in 1973 to that in 1974?
Keep it short and to the point. 1.69. What is the ratio of the Aid flow (current US$) of Sweden in 1973 to that in 1974?
Keep it short and to the point. 0.72. What is the ratio of the Aid flow (current US$) of Switzerland in 1973 to that in 1974?
Provide a succinct answer. 1.22. What is the ratio of the Aid flow (current US$) of Norway in 1973 to that in 1975?
Give a very brief answer. 0.33. What is the ratio of the Aid flow (current US$) in Portugal in 1973 to that in 1975?
Your response must be concise. 0.3. What is the ratio of the Aid flow (current US$) in Sweden in 1973 to that in 1975?
Keep it short and to the point. 1.05. What is the ratio of the Aid flow (current US$) in Switzerland in 1973 to that in 1975?
Offer a very short reply. 1.52. What is the ratio of the Aid flow (current US$) in Norway in 1974 to that in 1975?
Provide a succinct answer. 0.61. What is the ratio of the Aid flow (current US$) of Portugal in 1974 to that in 1975?
Provide a succinct answer. 0.18. What is the ratio of the Aid flow (current US$) of Sweden in 1974 to that in 1975?
Make the answer very short. 1.46. What is the ratio of the Aid flow (current US$) of Switzerland in 1974 to that in 1975?
Provide a succinct answer. 1.25. What is the difference between the highest and the second highest Aid flow (current US$) of Norway?
Provide a succinct answer. 4.50e+05. What is the difference between the highest and the second highest Aid flow (current US$) in Portugal?
Your answer should be very brief. 2.83e+06. What is the difference between the highest and the second highest Aid flow (current US$) of Sweden?
Ensure brevity in your answer.  4.75e+06. What is the difference between the highest and the second highest Aid flow (current US$) in Switzerland?
Provide a succinct answer. 4.60e+05. What is the difference between the highest and the lowest Aid flow (current US$) of Norway?
Your answer should be compact. 1.00e+06. What is the difference between the highest and the lowest Aid flow (current US$) in Portugal?
Provide a succinct answer. 3.66e+06. What is the difference between the highest and the lowest Aid flow (current US$) in Sweden?
Give a very brief answer. 1.45e+07. What is the difference between the highest and the lowest Aid flow (current US$) of Switzerland?
Keep it short and to the point. 1.34e+06. 